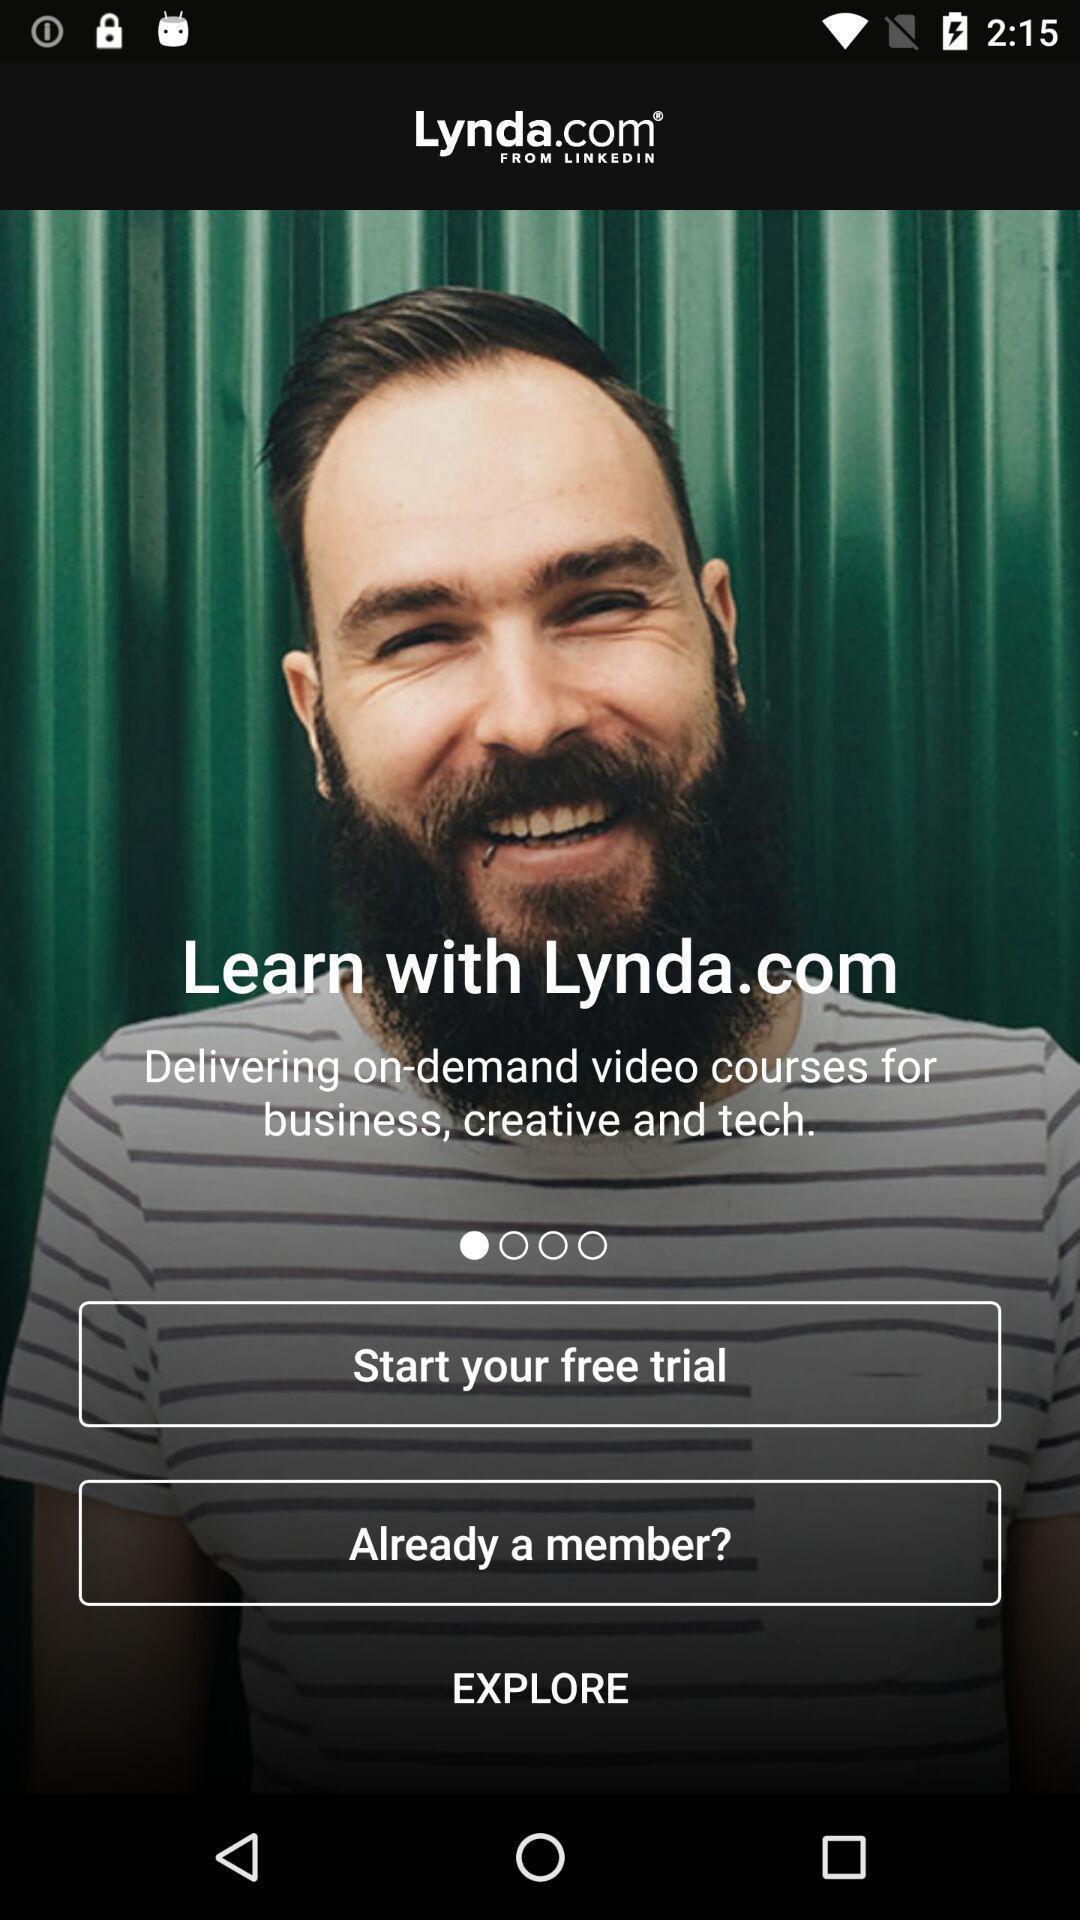Summarize the information in this screenshot. Welcome page. 